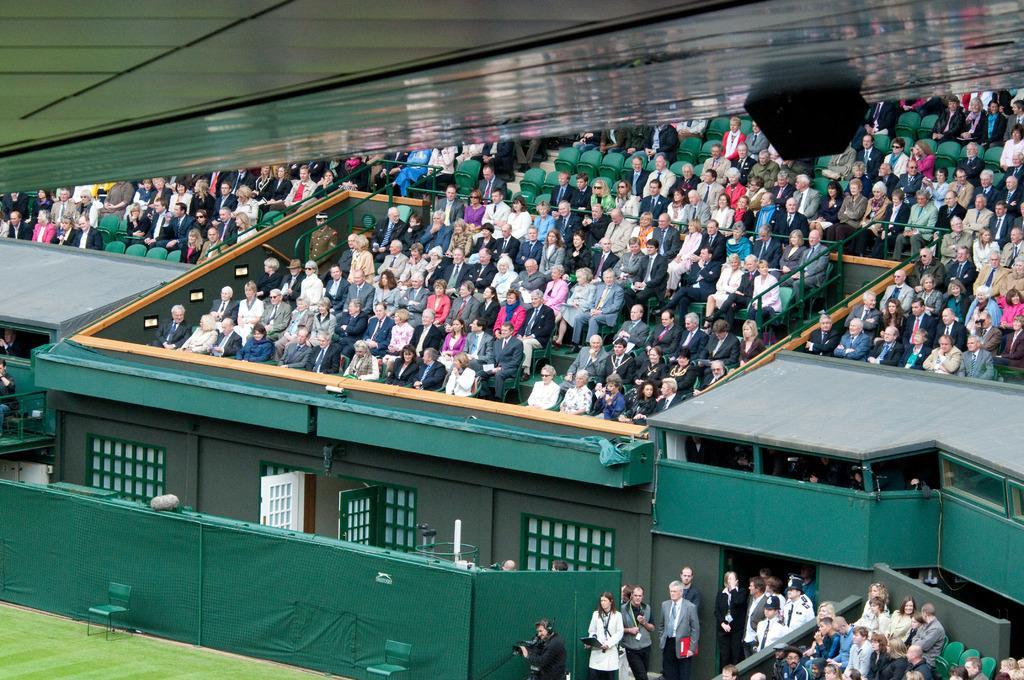Could you give a brief overview of what you see in this image? In this image we can see the spectators sitting on the chairs. Here we can see a few persons standing on the floor. Here we can see the fence which is covered with a green color cloth. Here we can see the chairs and grass on the bottom left side. 